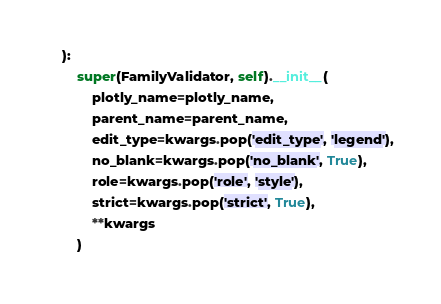<code> <loc_0><loc_0><loc_500><loc_500><_Python_>    ):
        super(FamilyValidator, self).__init__(
            plotly_name=plotly_name,
            parent_name=parent_name,
            edit_type=kwargs.pop('edit_type', 'legend'),
            no_blank=kwargs.pop('no_blank', True),
            role=kwargs.pop('role', 'style'),
            strict=kwargs.pop('strict', True),
            **kwargs
        )
</code> 